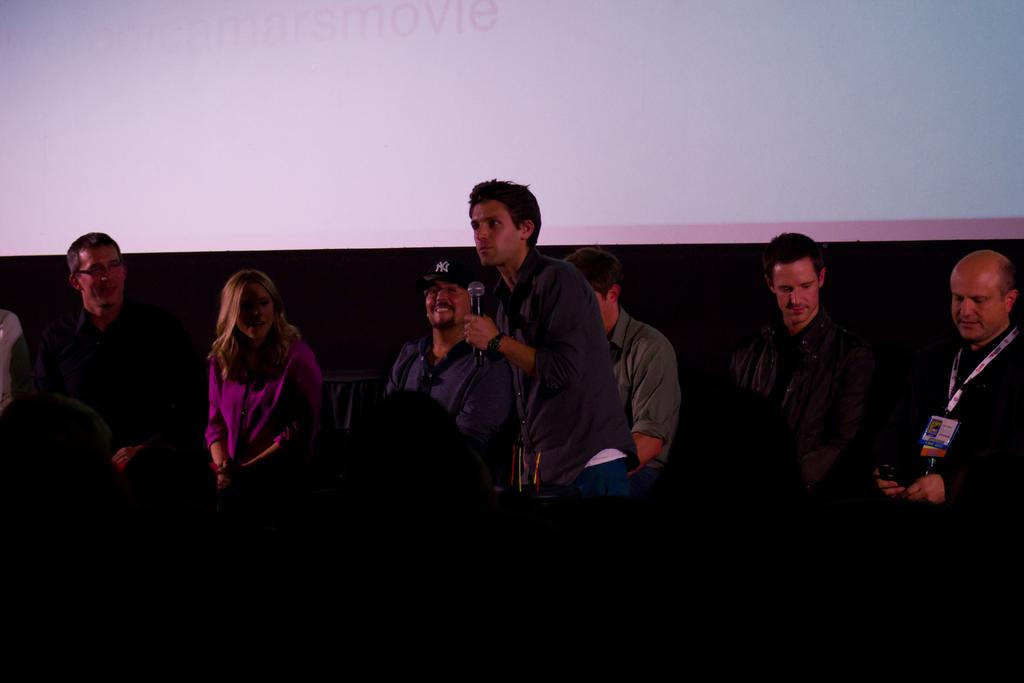What is the man in the foreground of the image doing? The man is holding a mic in the foreground of the image. What are the people around the man doing? The persons sitting around the man are likely listening or participating in the event. What can be seen in the background of the image? There is a screen in the background of the image. What type of clouds can be seen in the image? There are no clouds visible in the image; it features a man holding a mic, people sitting around him, and a screen in the background. 